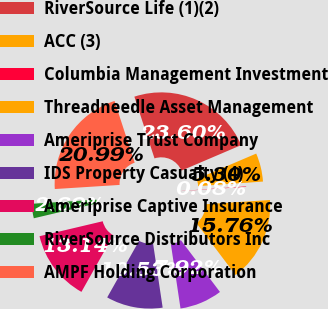<chart> <loc_0><loc_0><loc_500><loc_500><pie_chart><fcel>RiverSource Life (1)(2)<fcel>ACC (3)<fcel>Columbia Management Investment<fcel>Threadneedle Asset Management<fcel>Ameriprise Trust Company<fcel>IDS Property Casualty (4)<fcel>Ameriprise Captive Insurance<fcel>RiverSource Distributors Inc<fcel>AMPF Holding Corporation<nl><fcel>23.6%<fcel>5.3%<fcel>0.08%<fcel>15.76%<fcel>7.92%<fcel>10.53%<fcel>13.14%<fcel>2.69%<fcel>20.99%<nl></chart> 